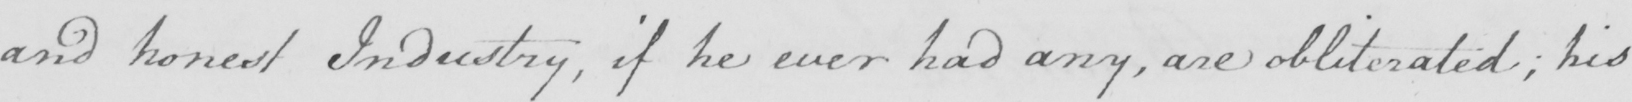Can you read and transcribe this handwriting? and honest Industry , if he ever had any , are obliterated ; his 